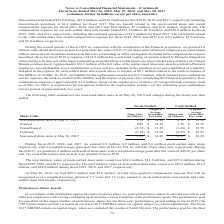According to Conagra Brands's financial document, Who receives the grant awards of restricted stock units and cash-settled restricted stock units ("share units") according to stockholder-approved equity incentive plans? Based on the financial document, the answer is employees and directors. Also, How much were the compensation expenses for the company’s stock-settled share unit awards for fiscal 2017, 2018, and 2019, respectively? The document contains multiple relevant values: $18.2 million, $21.8 million, $23.9 million. From the document: "share unit awards totaled $23.9 million, $21.8 million, and $18.2 million for fiscal 2019, 2018, and 2017, respectively, including discontinued operat..." Also, How much were the total intrinsic values of stock-settled share units during fiscal 2017 and 2018, respectively? The document shows two values: $27.0 million and $18.5 million. From the document: "units vested was $24.6 million, $18.5 million, and $27.0 million during tock-settled share units vested was $24.6 million, $18.5 million, and $27.0 mi..." Also, can you calculate: What is the ratio of the total price of stock-settled nonvested share units to the total intrinsic value of stock-settled share units vested during 2019? To answer this question, I need to perform calculations using the financial data. The calculation is: (1.81*34.89)/24.6 , which equals 2.57. This is based on the information: "Nonvested share units at May 26, 2019 . 1.81 $ 34.89 0.97 $ 36.20 Nonvested share units at May 26, 2019 . 1.81 $ 34.89 0.97 $ 36.20 ic value of stock-settled share units vested was $24.6 million, $18...." The key data points involved are: 1.81, 24.6, 34.89. Also, can you calculate: What is the total price of nonvested share units? Based on the calculation: (1.81*34.89)+(0.97*36.20) , the result is 98.26 (in millions). This is based on the information: "share units at May 26, 2019 . 1.81 $ 34.89 0.97 $ 36.20 Nonvested share units at May 26, 2019 . 1.81 $ 34.89 0.97 $ 36.20 Nonvested share units at May 26, 2019 . 1.81 $ 34.89 0.97 $ 36.20 vested share..." The key data points involved are: 0.97, 1.81, 34.89. Also, can you calculate: What is the average total price of granted share units for either stock-settled or cash-settled, during that year ? To answer this question, I need to perform calculations using the financial data. The calculation is: ((0.89*35.43)+(1.95*36.37))/2 , which equals 51.23 (in millions). This is based on the information: "Granted . 0.89 $ 35.43 1.95 $ 36.37 Granted . 0.89 $ 35.43 1.95 $ 36.37 Granted . 0.89 $ 35.43 1.95 $ 36.37 share unit awards at a grant date fair value of $36.37 per share unit to Pinnacle employees ..." The key data points involved are: 0.89, 1.95, 35.43. 